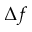<formula> <loc_0><loc_0><loc_500><loc_500>\Delta f</formula> 